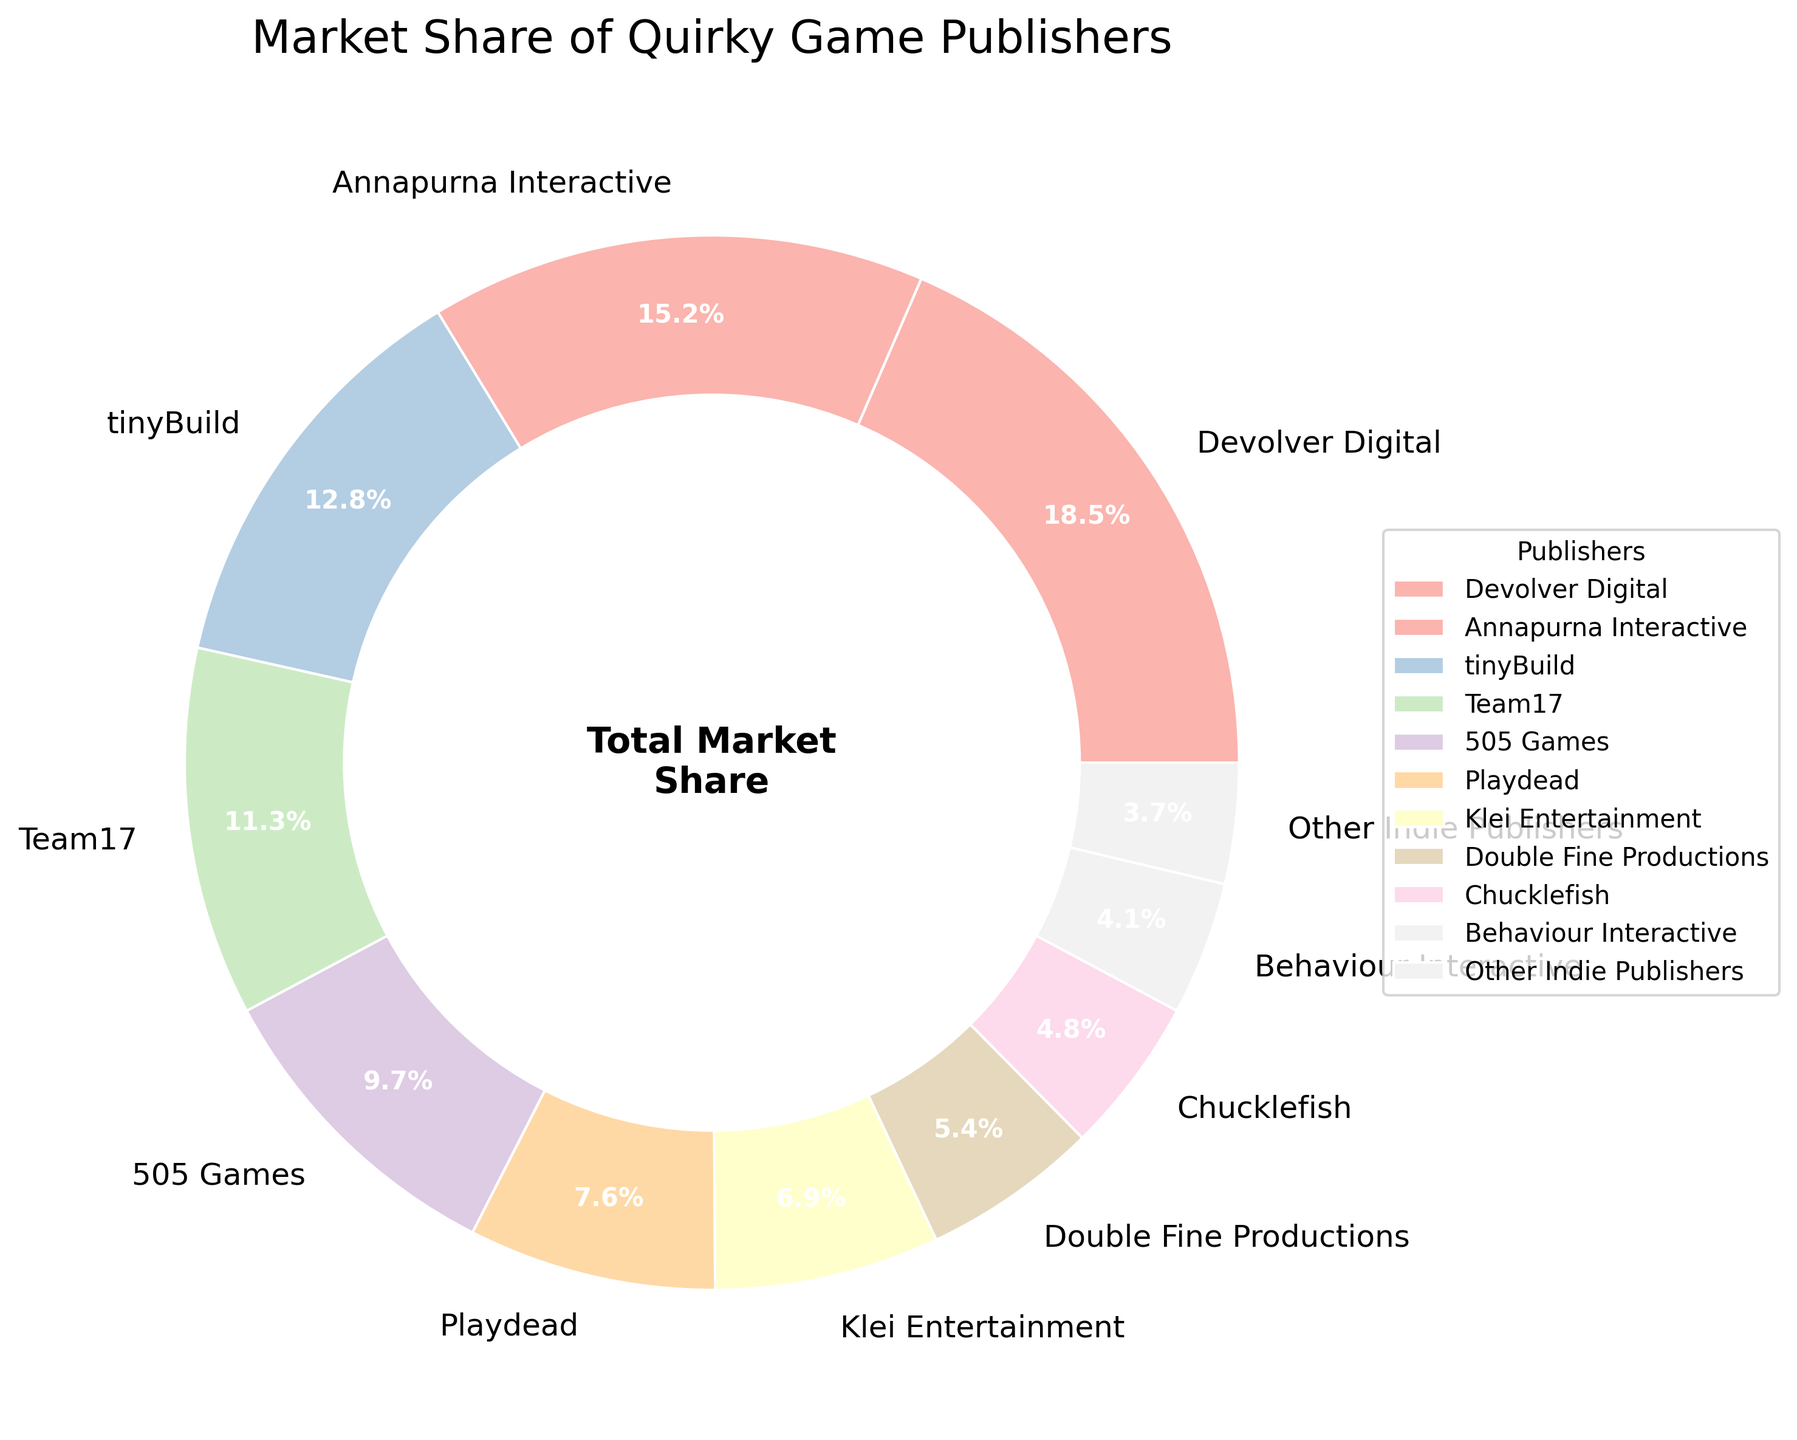What is the market share of the top three publishers? To find the market share of the top three publishers, identify the publishers with the highest market share and sum their percentages. The publishers with the highest market shares are Devolver Digital (18.5%), Annapurna Interactive (15.2%), and tinyBuild (12.8%). The total market share is 18.5 + 15.2 + 12.8 = 46.5%.
Answer: 46.5% Which publisher has the smallest market share? To determine the publisher with the smallest market share, look for the smallest percentage value among all the publishers. The publisher with the smallest market share is Behaviour Interactive with 4.1%.
Answer: Behaviour Interactive How much more market share does Devolver Digital have compared to Chucklefish? To find out how much more market share Devolver Digital has compared to Chucklefish, subtract the market share of Chucklefish from that of Devolver Digital. The calculation is 18.5% - 4.8% = 13.7%.
Answer: 13.7% What is the combined market share of Klei Entertainment, Double Fine Productions, and Chucklefish? To find the combined market share of these three publishers, sum their market shares. Klei Entertainment has 6.9%, Double Fine Productions has 5.4%, and Chucklefish has 4.8%. The total is 6.9 + 5.4 + 4.8 = 17.1%.
Answer: 17.1% Is Annapurna Interactive's market share greater than the combined market share of Behaviour Interactive and Other Indie Publishers? To compare Annapurna Interactive's market share with the combined market share of Behaviour Interactive and Other Indie Publishers, sum the market shares of Behaviour Interactive and Other Indie Publishers and compare the result with Annapurna Interactive's market share. Behaviour Interactive has 4.1% and Other Indie Publishers have 3.7%, so their combined market share is 4.1 + 3.7 = 7.8%. Annapurna Interactive's market share is 15.2%, which is greater than 7.8%.
Answer: Yes What fraction of the total market share do the bottom five publishers hold? To find the fraction of the total market share held by the bottom five publishers, identify the publishers with the smallest market shares and sum them, then divide by 100 to convert the percentage to a fraction. The bottom five publishers are Behaviour Interactive (4.1%), Other Indie Publishers (3.7%), Chucklefish (4.8%), Double Fine Productions (5.4%), and Klei Entertainment (6.9%). The combined market share is 4.1 + 3.7 + 4.8 + 5.4 + 6.9 = 24.9%. In fraction form, 24.9% is 24.9/100 = 0.249.
Answer: 0.249 Which publisher has a higher market share, Playdead or 505 Games? Compare the market share percentages of Playdead and 505 Games. Playdead has a market share of 7.6%, while 505 Games has 9.7%. Therefore, 505 Games has a higher market share.
Answer: 505 Games How does the market share of Team17 compare to tinyBuild? Compare the market share percentages of Team17 and tinyBuild. Team17 has a market share of 11.3% and tinyBuild has 12.8%. Since 12.8% is greater than 11.3%, tinyBuild has a higher market share.
Answer: tinyBuild What is the average market share of the publishers Devolver Digital, Annapurna Interactive, and tinyBuild? To find the average market share of these three publishers, sum their market shares and divide by the number of publishers. Devolver Digital has 18.5%, Annapurna Interactive has 15.2%, and tinyBuild has 12.8%. The total is 18.5 + 15.2 + 12.8 = 46.5%. The average is 46.5 / 3 = 15.5%.
Answer: 15.5% 